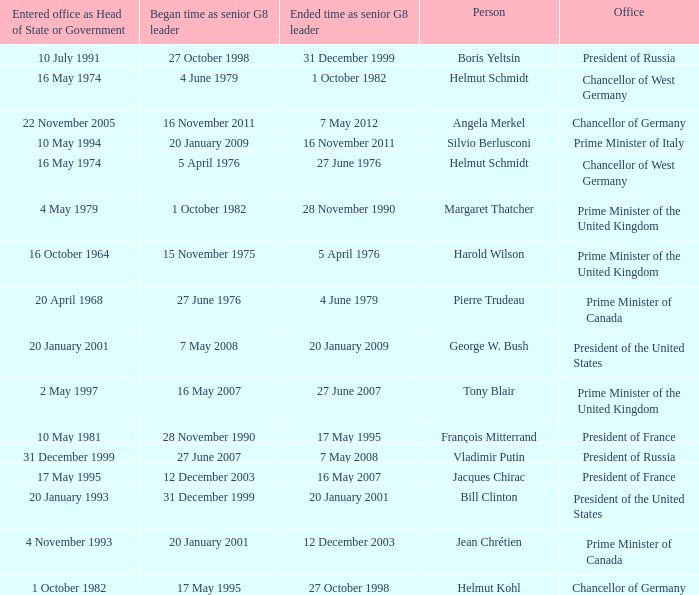When did Jacques Chirac stop being a G8 leader? 16 May 2007. 